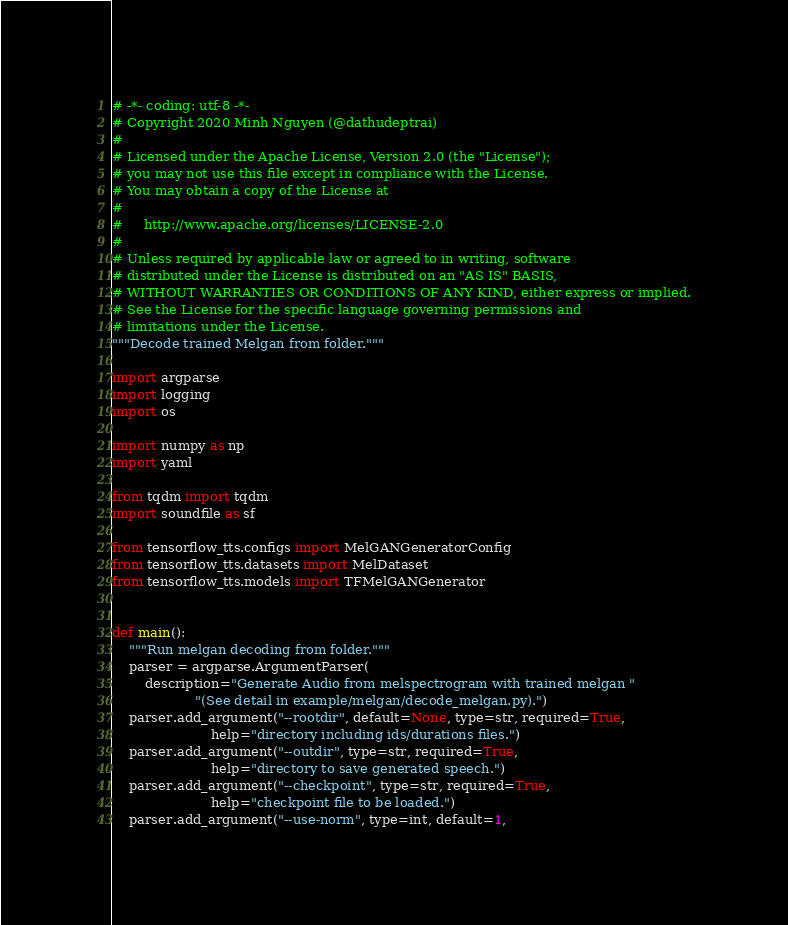<code> <loc_0><loc_0><loc_500><loc_500><_Python_># -*- coding: utf-8 -*-
# Copyright 2020 Minh Nguyen (@dathudeptrai)
#
# Licensed under the Apache License, Version 2.0 (the "License");
# you may not use this file except in compliance with the License.
# You may obtain a copy of the License at
#
#     http://www.apache.org/licenses/LICENSE-2.0
#
# Unless required by applicable law or agreed to in writing, software
# distributed under the License is distributed on an "AS IS" BASIS,
# WITHOUT WARRANTIES OR CONDITIONS OF ANY KIND, either express or implied.
# See the License for the specific language governing permissions and
# limitations under the License.
"""Decode trained Melgan from folder."""

import argparse
import logging
import os

import numpy as np
import yaml

from tqdm import tqdm
import soundfile as sf

from tensorflow_tts.configs import MelGANGeneratorConfig
from tensorflow_tts.datasets import MelDataset
from tensorflow_tts.models import TFMelGANGenerator


def main():
    """Run melgan decoding from folder."""
    parser = argparse.ArgumentParser(
        description="Generate Audio from melspectrogram with trained melgan "
                    "(See detail in example/melgan/decode_melgan.py).")
    parser.add_argument("--rootdir", default=None, type=str, required=True,
                        help="directory including ids/durations files.")
    parser.add_argument("--outdir", type=str, required=True,
                        help="directory to save generated speech.")
    parser.add_argument("--checkpoint", type=str, required=True,
                        help="checkpoint file to be loaded.")
    parser.add_argument("--use-norm", type=int, default=1,</code> 